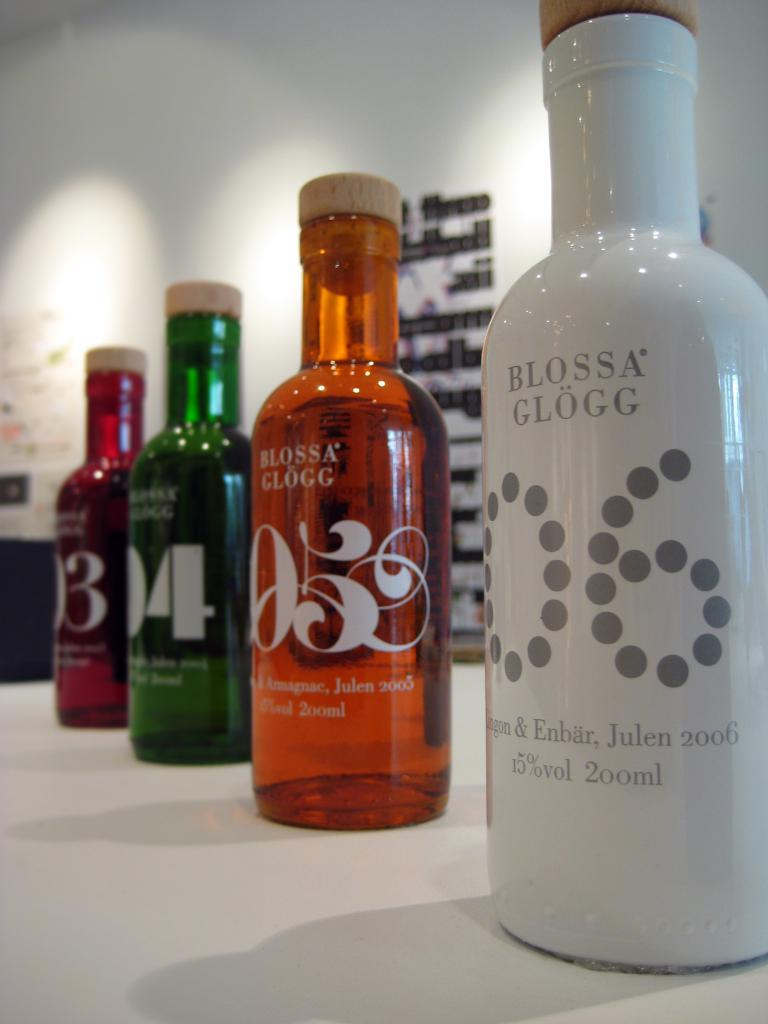Provide a one-sentence caption for the provided image. Four bottles of Blossa Glogg are lined up on a table, all different colors. 